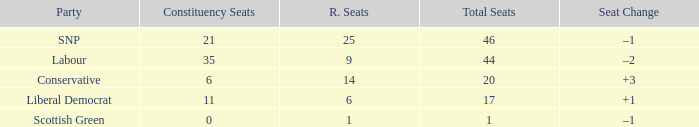What is the full number of Total Seats with a constituency seat number bigger than 0 with the Liberal Democrat party, and the Regional seat number is smaller than 6? None. 